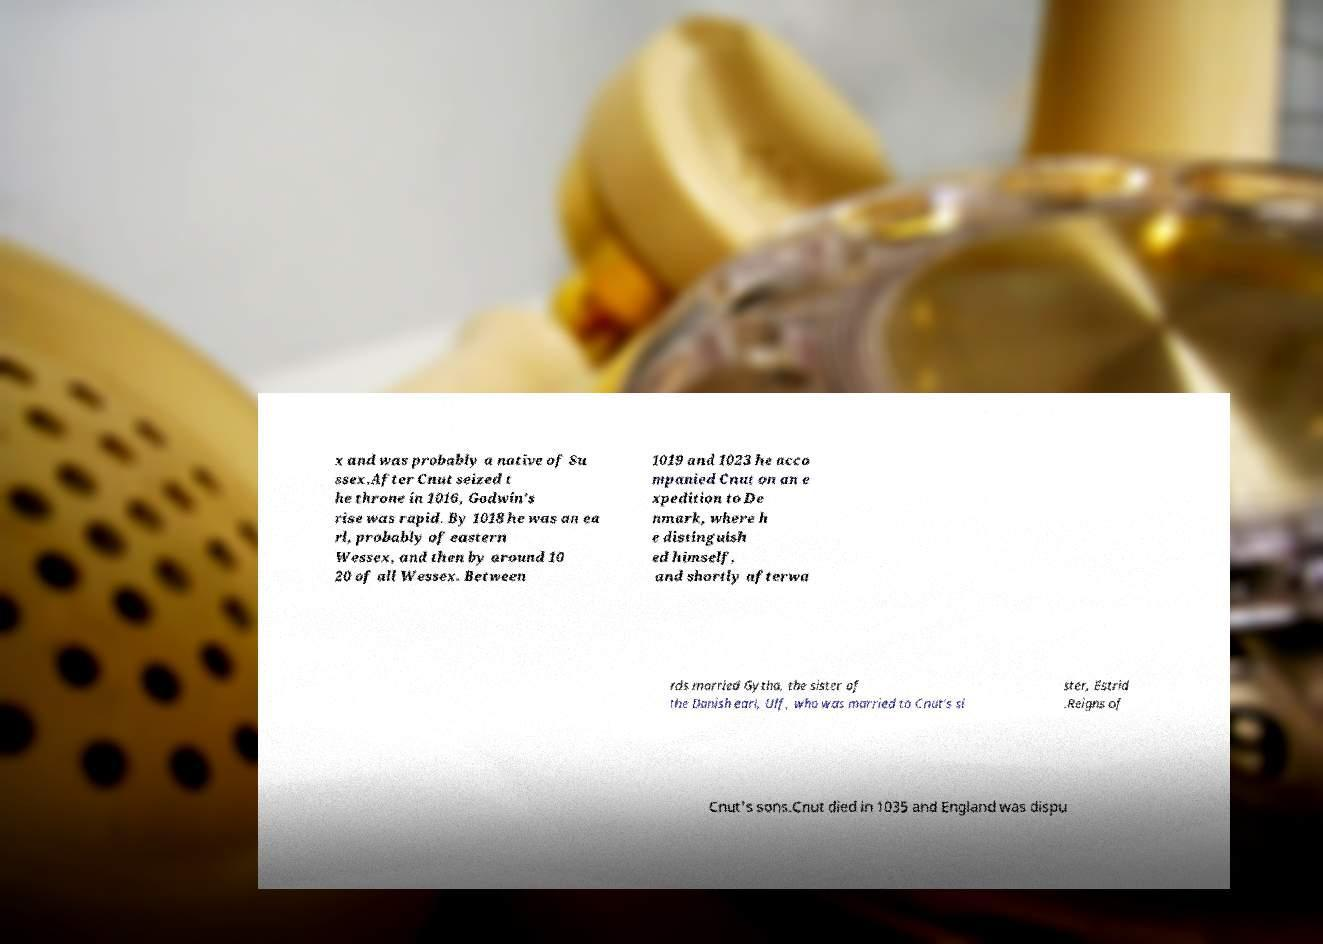I need the written content from this picture converted into text. Can you do that? x and was probably a native of Su ssex.After Cnut seized t he throne in 1016, Godwin's rise was rapid. By 1018 he was an ea rl, probably of eastern Wessex, and then by around 10 20 of all Wessex. Between 1019 and 1023 he acco mpanied Cnut on an e xpedition to De nmark, where h e distinguish ed himself, and shortly afterwa rds married Gytha, the sister of the Danish earl, Ulf, who was married to Cnut's si ster, Estrid .Reigns of Cnut's sons.Cnut died in 1035 and England was dispu 